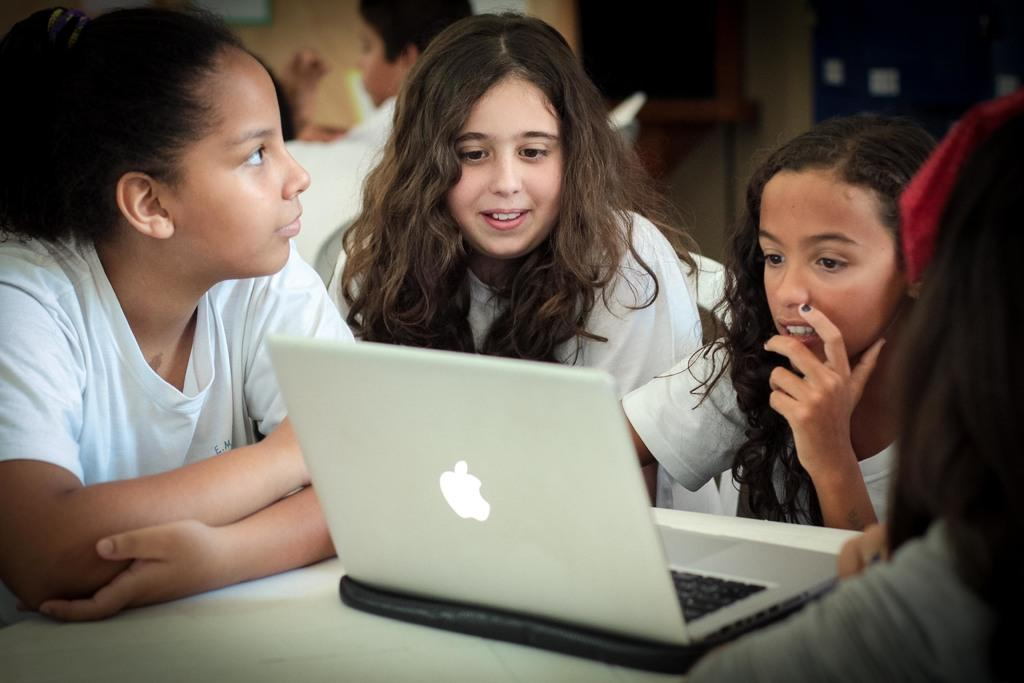Who is present in the image? There are kids in the image. What are the kids doing in the image? The kids are watching something on a laptop. What type of key is being used to unlock the library in the image? There is no library or key present in the image; it features kids watching something on a laptop. What is the rate of the internet connection being used by the kids in the image? The provided facts do not mention the internet connection or its speed, so it cannot be determined from the image. 